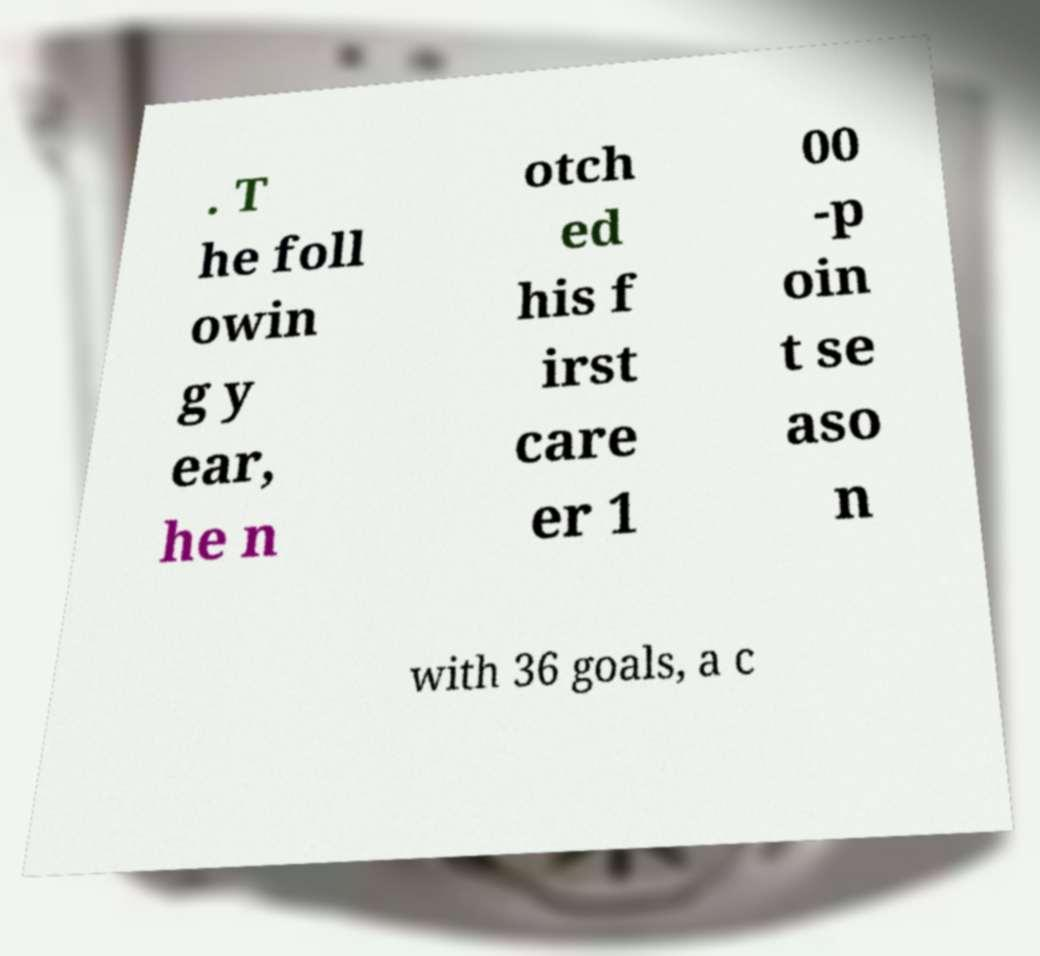There's text embedded in this image that I need extracted. Can you transcribe it verbatim? . T he foll owin g y ear, he n otch ed his f irst care er 1 00 -p oin t se aso n with 36 goals, a c 